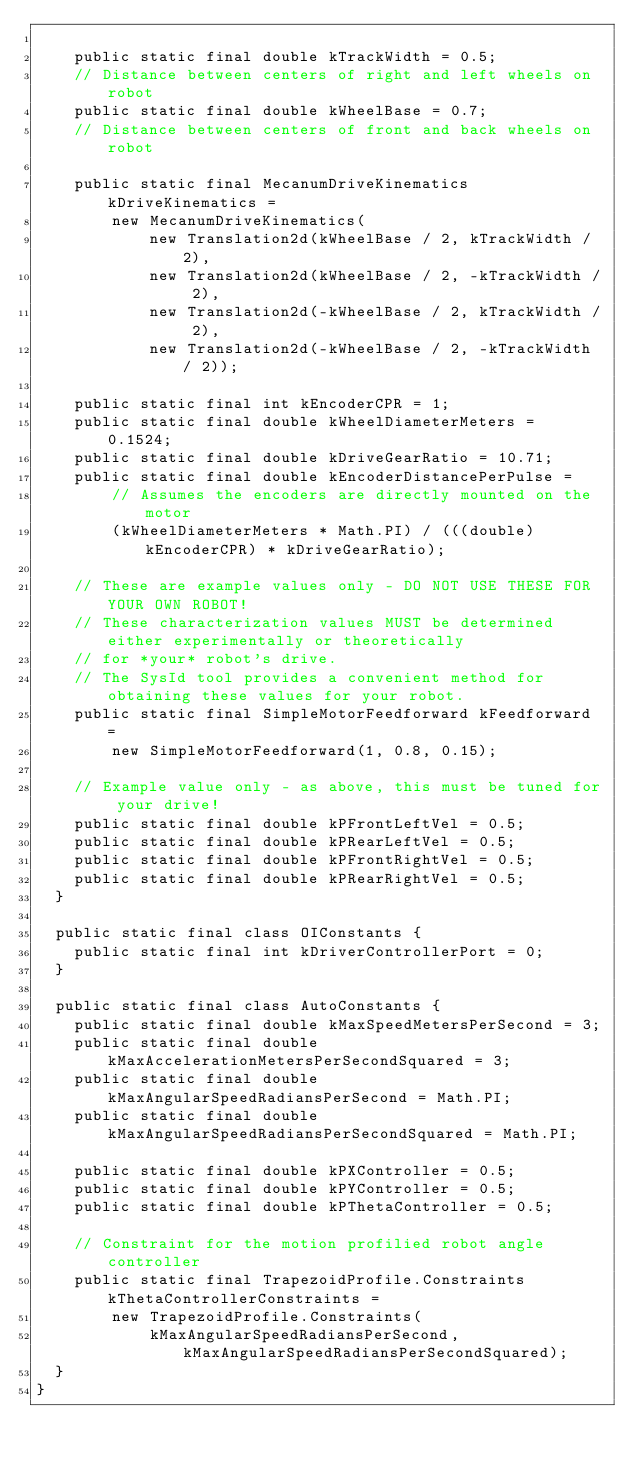<code> <loc_0><loc_0><loc_500><loc_500><_Java_>
    public static final double kTrackWidth = 0.5;
    // Distance between centers of right and left wheels on robot
    public static final double kWheelBase = 0.7;
    // Distance between centers of front and back wheels on robot

    public static final MecanumDriveKinematics kDriveKinematics =
        new MecanumDriveKinematics(
            new Translation2d(kWheelBase / 2, kTrackWidth / 2),
            new Translation2d(kWheelBase / 2, -kTrackWidth / 2),
            new Translation2d(-kWheelBase / 2, kTrackWidth / 2),
            new Translation2d(-kWheelBase / 2, -kTrackWidth / 2));

    public static final int kEncoderCPR = 1;
    public static final double kWheelDiameterMeters = 0.1524;
    public static final double kDriveGearRatio = 10.71;
    public static final double kEncoderDistancePerPulse =
        // Assumes the encoders are directly mounted on the motor
        (kWheelDiameterMeters * Math.PI) / (((double) kEncoderCPR) * kDriveGearRatio);

    // These are example values only - DO NOT USE THESE FOR YOUR OWN ROBOT!
    // These characterization values MUST be determined either experimentally or theoretically
    // for *your* robot's drive.
    // The SysId tool provides a convenient method for obtaining these values for your robot.
    public static final SimpleMotorFeedforward kFeedforward =
        new SimpleMotorFeedforward(1, 0.8, 0.15);

    // Example value only - as above, this must be tuned for your drive!
    public static final double kPFrontLeftVel = 0.5;
    public static final double kPRearLeftVel = 0.5;
    public static final double kPFrontRightVel = 0.5;
    public static final double kPRearRightVel = 0.5;
  }

  public static final class OIConstants {
    public static final int kDriverControllerPort = 0;
  }

  public static final class AutoConstants {
    public static final double kMaxSpeedMetersPerSecond = 3;
    public static final double kMaxAccelerationMetersPerSecondSquared = 3;
    public static final double kMaxAngularSpeedRadiansPerSecond = Math.PI;
    public static final double kMaxAngularSpeedRadiansPerSecondSquared = Math.PI;

    public static final double kPXController = 0.5;
    public static final double kPYController = 0.5;
    public static final double kPThetaController = 0.5;

    // Constraint for the motion profilied robot angle controller
    public static final TrapezoidProfile.Constraints kThetaControllerConstraints =
        new TrapezoidProfile.Constraints(
            kMaxAngularSpeedRadiansPerSecond, kMaxAngularSpeedRadiansPerSecondSquared);
  }
}
</code> 